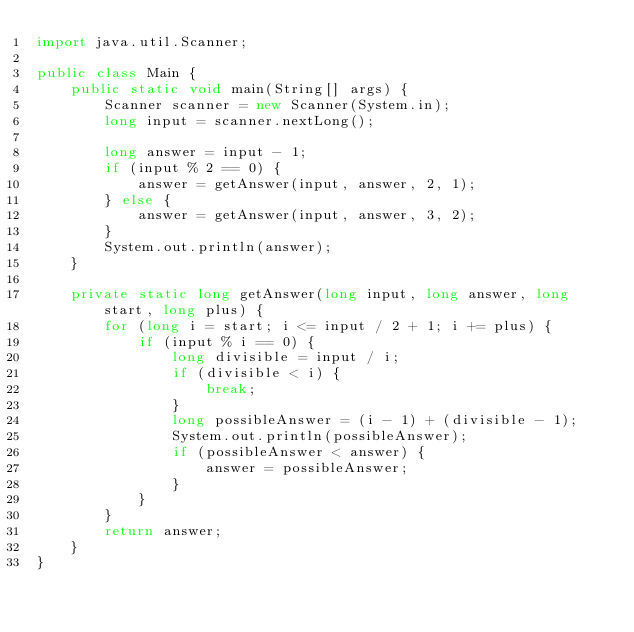<code> <loc_0><loc_0><loc_500><loc_500><_Java_>import java.util.Scanner;

public class Main {
    public static void main(String[] args) {
        Scanner scanner = new Scanner(System.in);
        long input = scanner.nextLong();

        long answer = input - 1;
        if (input % 2 == 0) {
            answer = getAnswer(input, answer, 2, 1);
        } else {
            answer = getAnswer(input, answer, 3, 2);
        }
        System.out.println(answer);
    }

    private static long getAnswer(long input, long answer, long start, long plus) {
        for (long i = start; i <= input / 2 + 1; i += plus) {
            if (input % i == 0) {
                long divisible = input / i;
                if (divisible < i) {
                    break;
                }
                long possibleAnswer = (i - 1) + (divisible - 1);
                System.out.println(possibleAnswer);
                if (possibleAnswer < answer) {
                    answer = possibleAnswer;
                }
            }
        }
        return answer;
    }
}</code> 